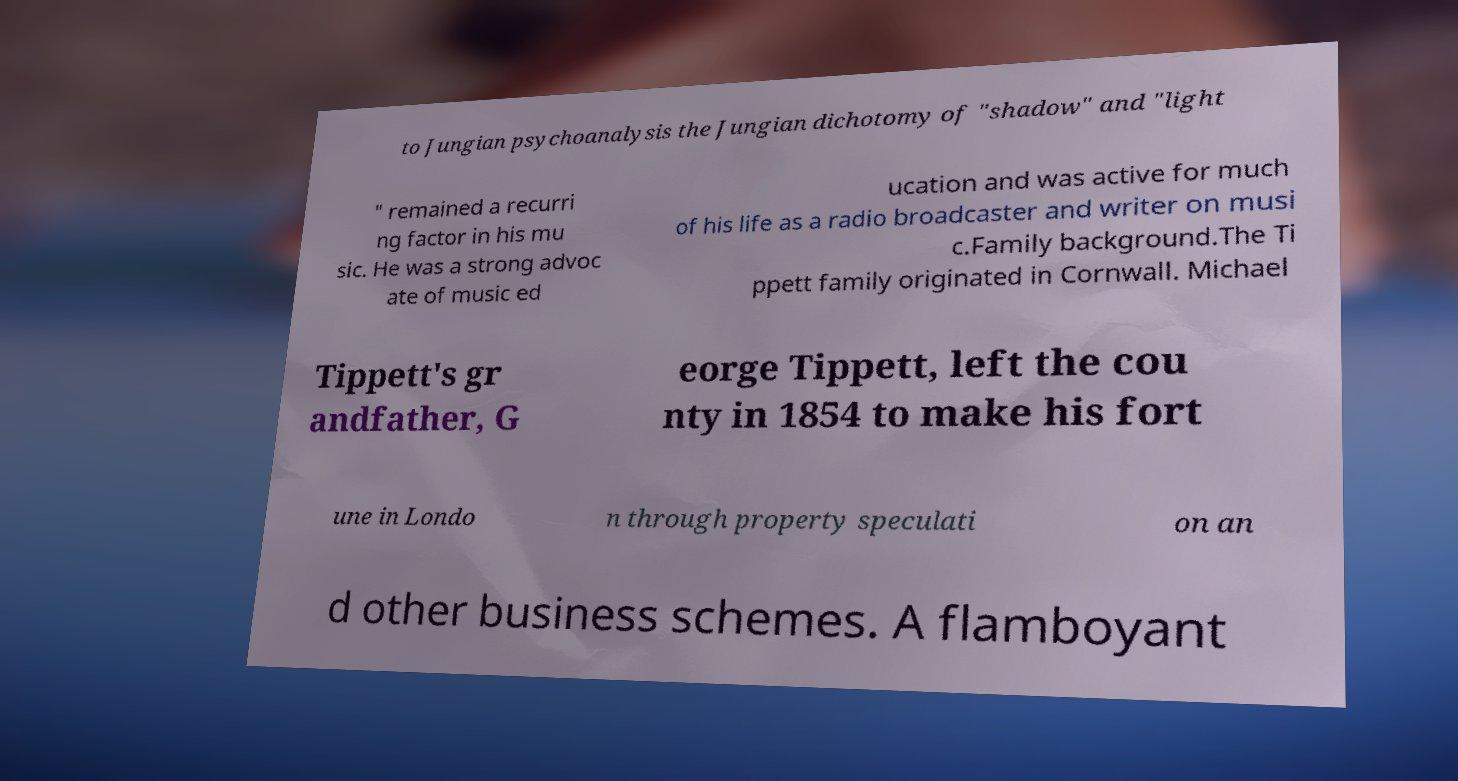Could you assist in decoding the text presented in this image and type it out clearly? to Jungian psychoanalysis the Jungian dichotomy of "shadow" and "light " remained a recurri ng factor in his mu sic. He was a strong advoc ate of music ed ucation and was active for much of his life as a radio broadcaster and writer on musi c.Family background.The Ti ppett family originated in Cornwall. Michael Tippett's gr andfather, G eorge Tippett, left the cou nty in 1854 to make his fort une in Londo n through property speculati on an d other business schemes. A flamboyant 